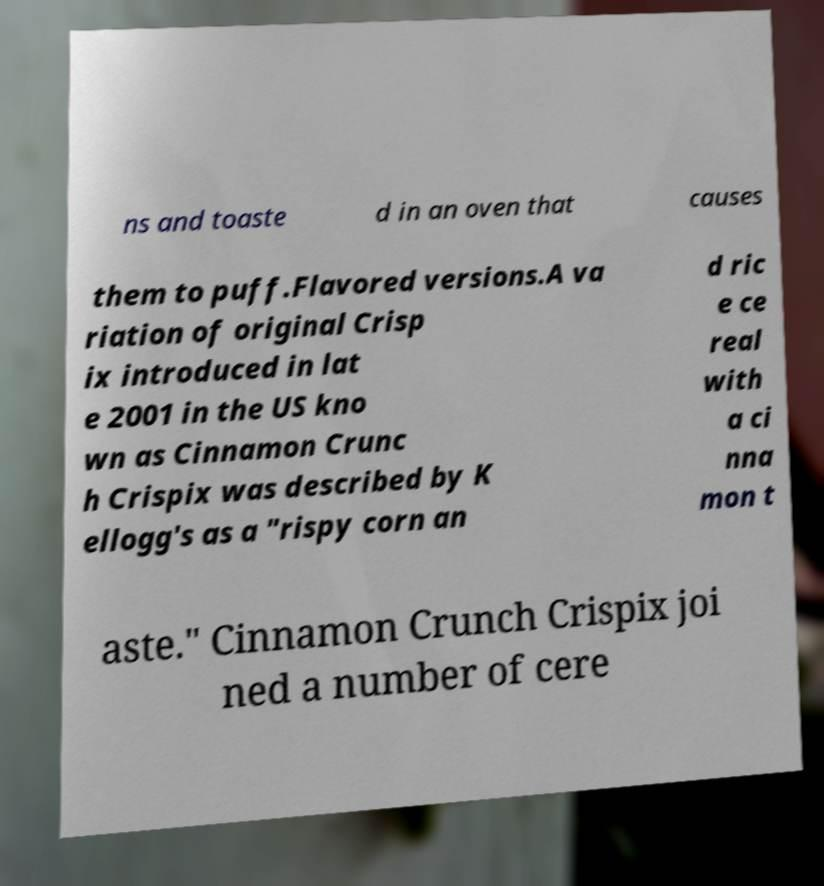Please read and relay the text visible in this image. What does it say? ns and toaste d in an oven that causes them to puff.Flavored versions.A va riation of original Crisp ix introduced in lat e 2001 in the US kno wn as Cinnamon Crunc h Crispix was described by K ellogg's as a "rispy corn an d ric e ce real with a ci nna mon t aste." Cinnamon Crunch Crispix joi ned a number of cere 